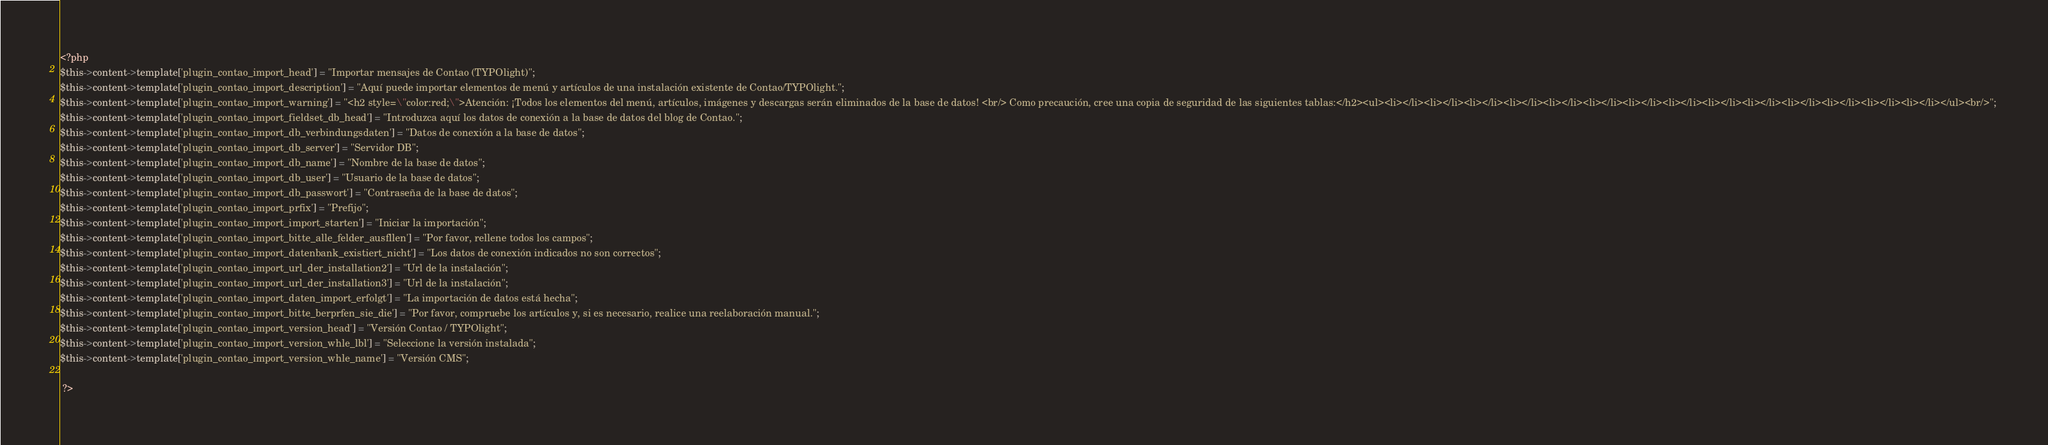<code> <loc_0><loc_0><loc_500><loc_500><_PHP_><?php 
$this->content->template['plugin_contao_import_head'] = "Importar mensajes de Contao (TYPOlight)"; 
$this->content->template['plugin_contao_import_description'] = "Aquí puede importar elementos de menú y artículos de una instalación existente de Contao/TYPOlight."; 
$this->content->template['plugin_contao_import_warning'] = "<h2 style=\"color:red;\">Atención: ¡Todos los elementos del menú, artículos, imágenes y descargas serán eliminados de la base de datos! <br/> Como precaución, cree una copia de seguridad de las siguientes tablas:</h2><ul><li></li><li></li><li></li><li></li><li></li><li></li><li></li><li></li><li></li><li></li><li></li><li></li><li></li><li></li></ul><br/>"; 
$this->content->template['plugin_contao_import_fieldset_db_head'] = "Introduzca aquí los datos de conexión a la base de datos del blog de Contao."; 
$this->content->template['plugin_contao_import_db_verbindungsdaten'] = "Datos de conexión a la base de datos"; 
$this->content->template['plugin_contao_import_db_server'] = "Servidor DB"; 
$this->content->template['plugin_contao_import_db_name'] = "Nombre de la base de datos"; 
$this->content->template['plugin_contao_import_db_user'] = "Usuario de la base de datos"; 
$this->content->template['plugin_contao_import_db_passwort'] = "Contraseña de la base de datos"; 
$this->content->template['plugin_contao_import_prfix'] = "Prefijo"; 
$this->content->template['plugin_contao_import_import_starten'] = "Iniciar la importación"; 
$this->content->template['plugin_contao_import_bitte_alle_felder_ausfllen'] = "Por favor, rellene todos los campos"; 
$this->content->template['plugin_contao_import_datenbank_existiert_nicht'] = "Los datos de conexión indicados no son correctos"; 
$this->content->template['plugin_contao_import_url_der_installation2'] = "Url de la instalación"; 
$this->content->template['plugin_contao_import_url_der_installation3'] = "Url de la instalación"; 
$this->content->template['plugin_contao_import_daten_import_erfolgt'] = "La importación de datos está hecha"; 
$this->content->template['plugin_contao_import_bitte_berprfen_sie_die'] = "Por favor, compruebe los artículos y, si es necesario, realice una reelaboración manual."; 
$this->content->template['plugin_contao_import_version_head'] = "Versión Contao / TYPOlight"; 
$this->content->template['plugin_contao_import_version_whle_lbl'] = "Seleccione la versión instalada"; 
$this->content->template['plugin_contao_import_version_whle_name'] = "Versión CMS"; 

 ?></code> 